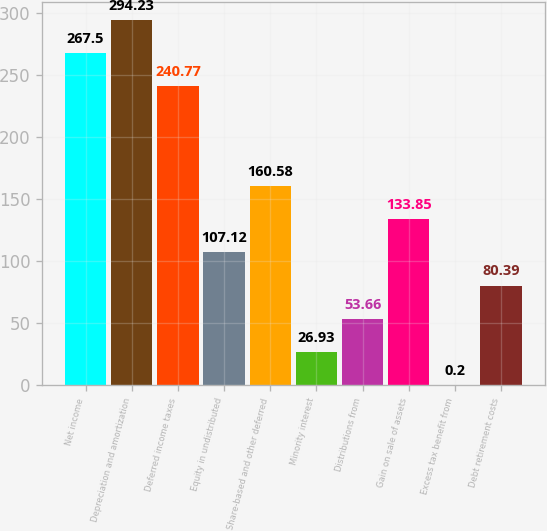<chart> <loc_0><loc_0><loc_500><loc_500><bar_chart><fcel>Net income<fcel>Depreciation and amortization<fcel>Deferred income taxes<fcel>Equity in undistributed<fcel>Share-based and other deferred<fcel>Minority interest<fcel>Distributions from<fcel>Gain on sale of assets<fcel>Excess tax benefit from<fcel>Debt retirement costs<nl><fcel>267.5<fcel>294.23<fcel>240.77<fcel>107.12<fcel>160.58<fcel>26.93<fcel>53.66<fcel>133.85<fcel>0.2<fcel>80.39<nl></chart> 